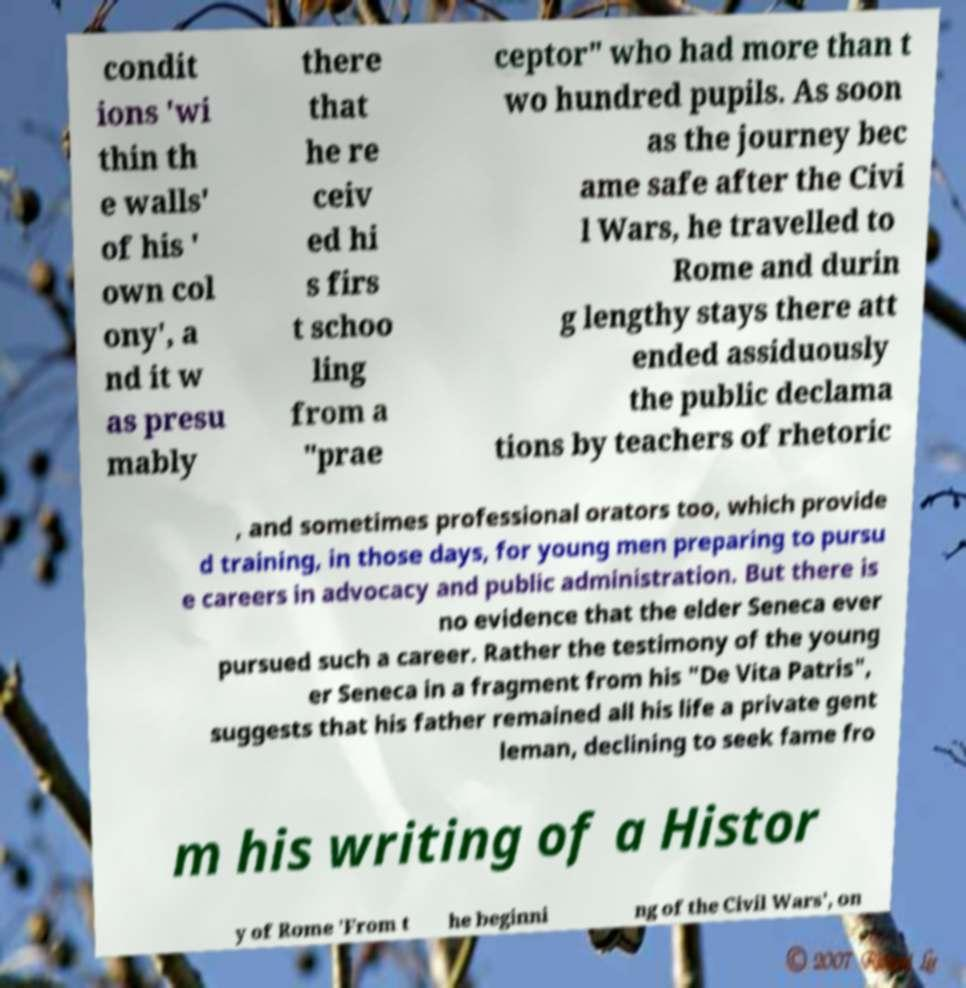Can you accurately transcribe the text from the provided image for me? condit ions 'wi thin th e walls' of his ' own col ony', a nd it w as presu mably there that he re ceiv ed hi s firs t schoo ling from a "prae ceptor" who had more than t wo hundred pupils. As soon as the journey bec ame safe after the Civi l Wars, he travelled to Rome and durin g lengthy stays there att ended assiduously the public declama tions by teachers of rhetoric , and sometimes professional orators too, which provide d training, in those days, for young men preparing to pursu e careers in advocacy and public administration. But there is no evidence that the elder Seneca ever pursued such a career. Rather the testimony of the young er Seneca in a fragment from his "De Vita Patris", suggests that his father remained all his life a private gent leman, declining to seek fame fro m his writing of a Histor y of Rome 'From t he beginni ng of the Civil Wars', on 